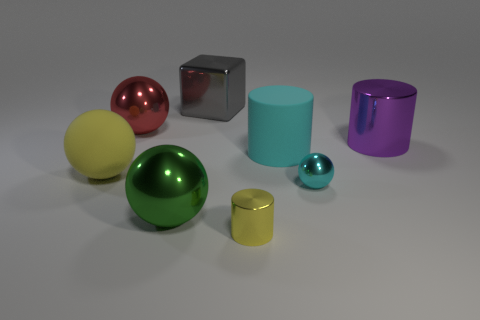Are there any small metallic objects on the right side of the small cylinder?
Ensure brevity in your answer.  Yes. What number of other things are there of the same shape as the big gray object?
Your answer should be very brief. 0. There is a matte ball that is the same size as the matte cylinder; what is its color?
Ensure brevity in your answer.  Yellow. Is the number of green spheres behind the metallic cube less than the number of green shiny spheres that are in front of the purple cylinder?
Keep it short and to the point. Yes. There is a small metal object that is behind the yellow object to the right of the red metal thing; what number of small cyan metal things are to the left of it?
Keep it short and to the point. 0. There is a green metallic thing that is the same shape as the red thing; what size is it?
Give a very brief answer. Large. Are there fewer big metallic objects behind the tiny cyan shiny sphere than things?
Your answer should be very brief. Yes. Does the tiny yellow thing have the same shape as the red object?
Offer a terse response. No. There is a large rubber object that is the same shape as the small cyan shiny object; what color is it?
Your response must be concise. Yellow. How many big metal blocks are the same color as the tiny metal cylinder?
Your response must be concise. 0. 